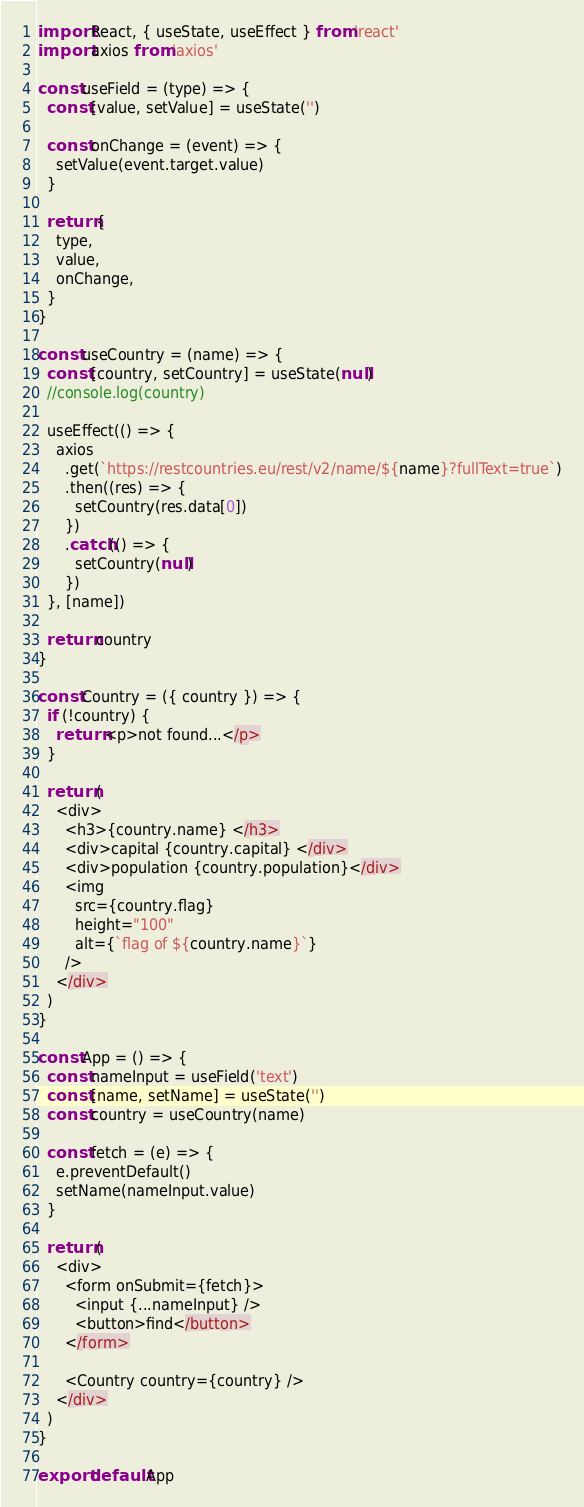Convert code to text. <code><loc_0><loc_0><loc_500><loc_500><_JavaScript_>import React, { useState, useEffect } from 'react'
import axios from 'axios'

const useField = (type) => {
  const [value, setValue] = useState('')

  const onChange = (event) => {
    setValue(event.target.value)
  }

  return {
    type,
    value,
    onChange,
  }
}

const useCountry = (name) => {
  const [country, setCountry] = useState(null)
  //console.log(country)

  useEffect(() => {
    axios
      .get(`https://restcountries.eu/rest/v2/name/${name}?fullText=true`)
      .then((res) => {
        setCountry(res.data[0])
      })
      .catch(() => {
        setCountry(null)
      })
  }, [name])

  return country
}

const Country = ({ country }) => {
  if (!country) {
    return <p>not found...</p>
  }

  return (
    <div>
      <h3>{country.name} </h3>
      <div>capital {country.capital} </div>
      <div>population {country.population}</div>
      <img
        src={country.flag}
        height="100"
        alt={`flag of ${country.name}`}
      />
    </div>
  )
}

const App = () => {
  const nameInput = useField('text')
  const [name, setName] = useState('')
  const country = useCountry(name)

  const fetch = (e) => {
    e.preventDefault()
    setName(nameInput.value)
  }

  return (
    <div>
      <form onSubmit={fetch}>
        <input {...nameInput} />
        <button>find</button>
      </form>

      <Country country={country} />
    </div>
  )
}

export default App
</code> 